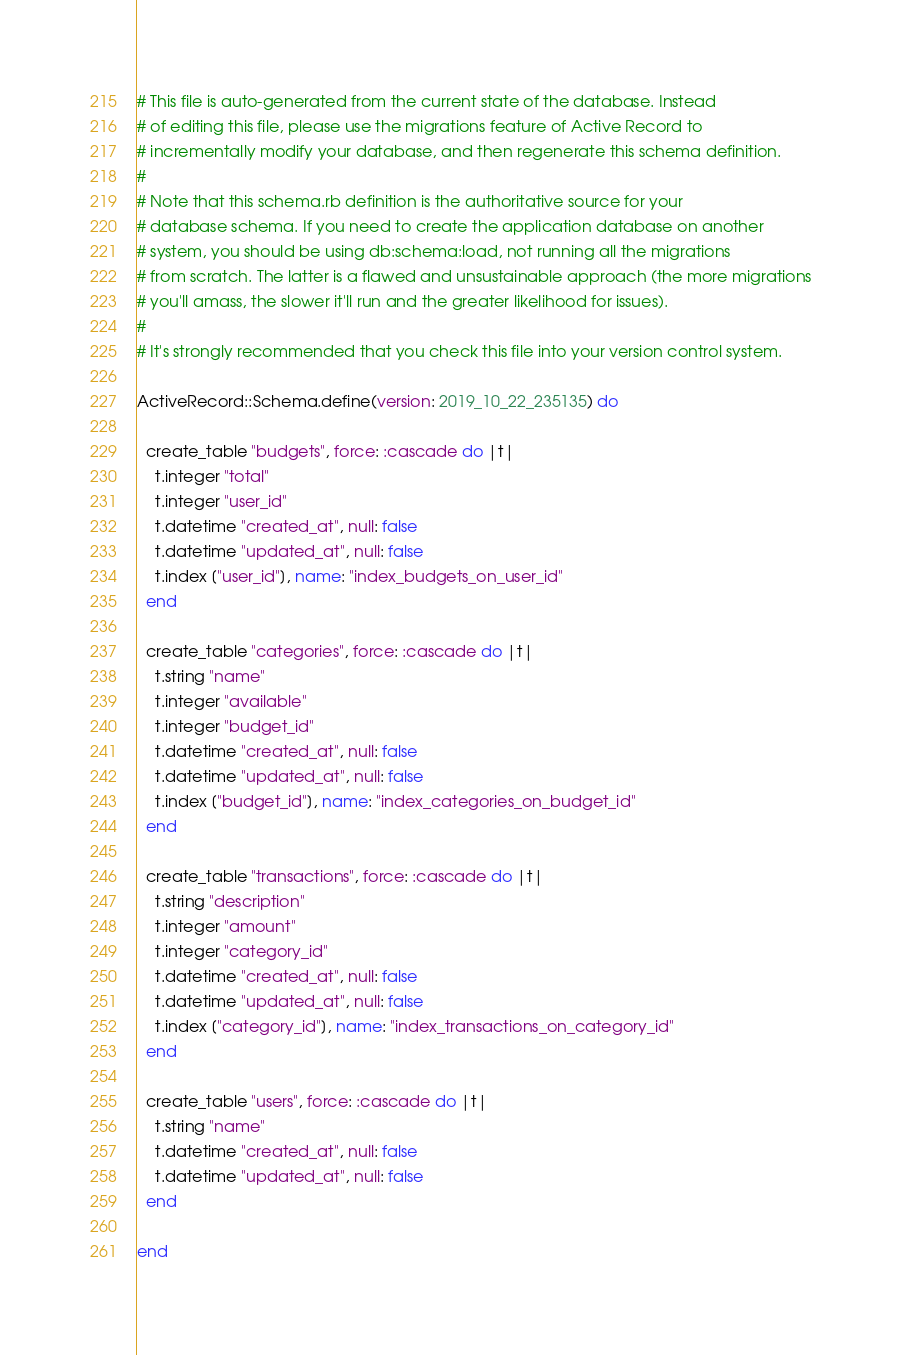<code> <loc_0><loc_0><loc_500><loc_500><_Ruby_># This file is auto-generated from the current state of the database. Instead
# of editing this file, please use the migrations feature of Active Record to
# incrementally modify your database, and then regenerate this schema definition.
#
# Note that this schema.rb definition is the authoritative source for your
# database schema. If you need to create the application database on another
# system, you should be using db:schema:load, not running all the migrations
# from scratch. The latter is a flawed and unsustainable approach (the more migrations
# you'll amass, the slower it'll run and the greater likelihood for issues).
#
# It's strongly recommended that you check this file into your version control system.

ActiveRecord::Schema.define(version: 2019_10_22_235135) do

  create_table "budgets", force: :cascade do |t|
    t.integer "total"
    t.integer "user_id"
    t.datetime "created_at", null: false
    t.datetime "updated_at", null: false
    t.index ["user_id"], name: "index_budgets_on_user_id"
  end

  create_table "categories", force: :cascade do |t|
    t.string "name"
    t.integer "available"
    t.integer "budget_id"
    t.datetime "created_at", null: false
    t.datetime "updated_at", null: false
    t.index ["budget_id"], name: "index_categories_on_budget_id"
  end

  create_table "transactions", force: :cascade do |t|
    t.string "description"
    t.integer "amount"
    t.integer "category_id"
    t.datetime "created_at", null: false
    t.datetime "updated_at", null: false
    t.index ["category_id"], name: "index_transactions_on_category_id"
  end

  create_table "users", force: :cascade do |t|
    t.string "name"
    t.datetime "created_at", null: false
    t.datetime "updated_at", null: false
  end

end
</code> 